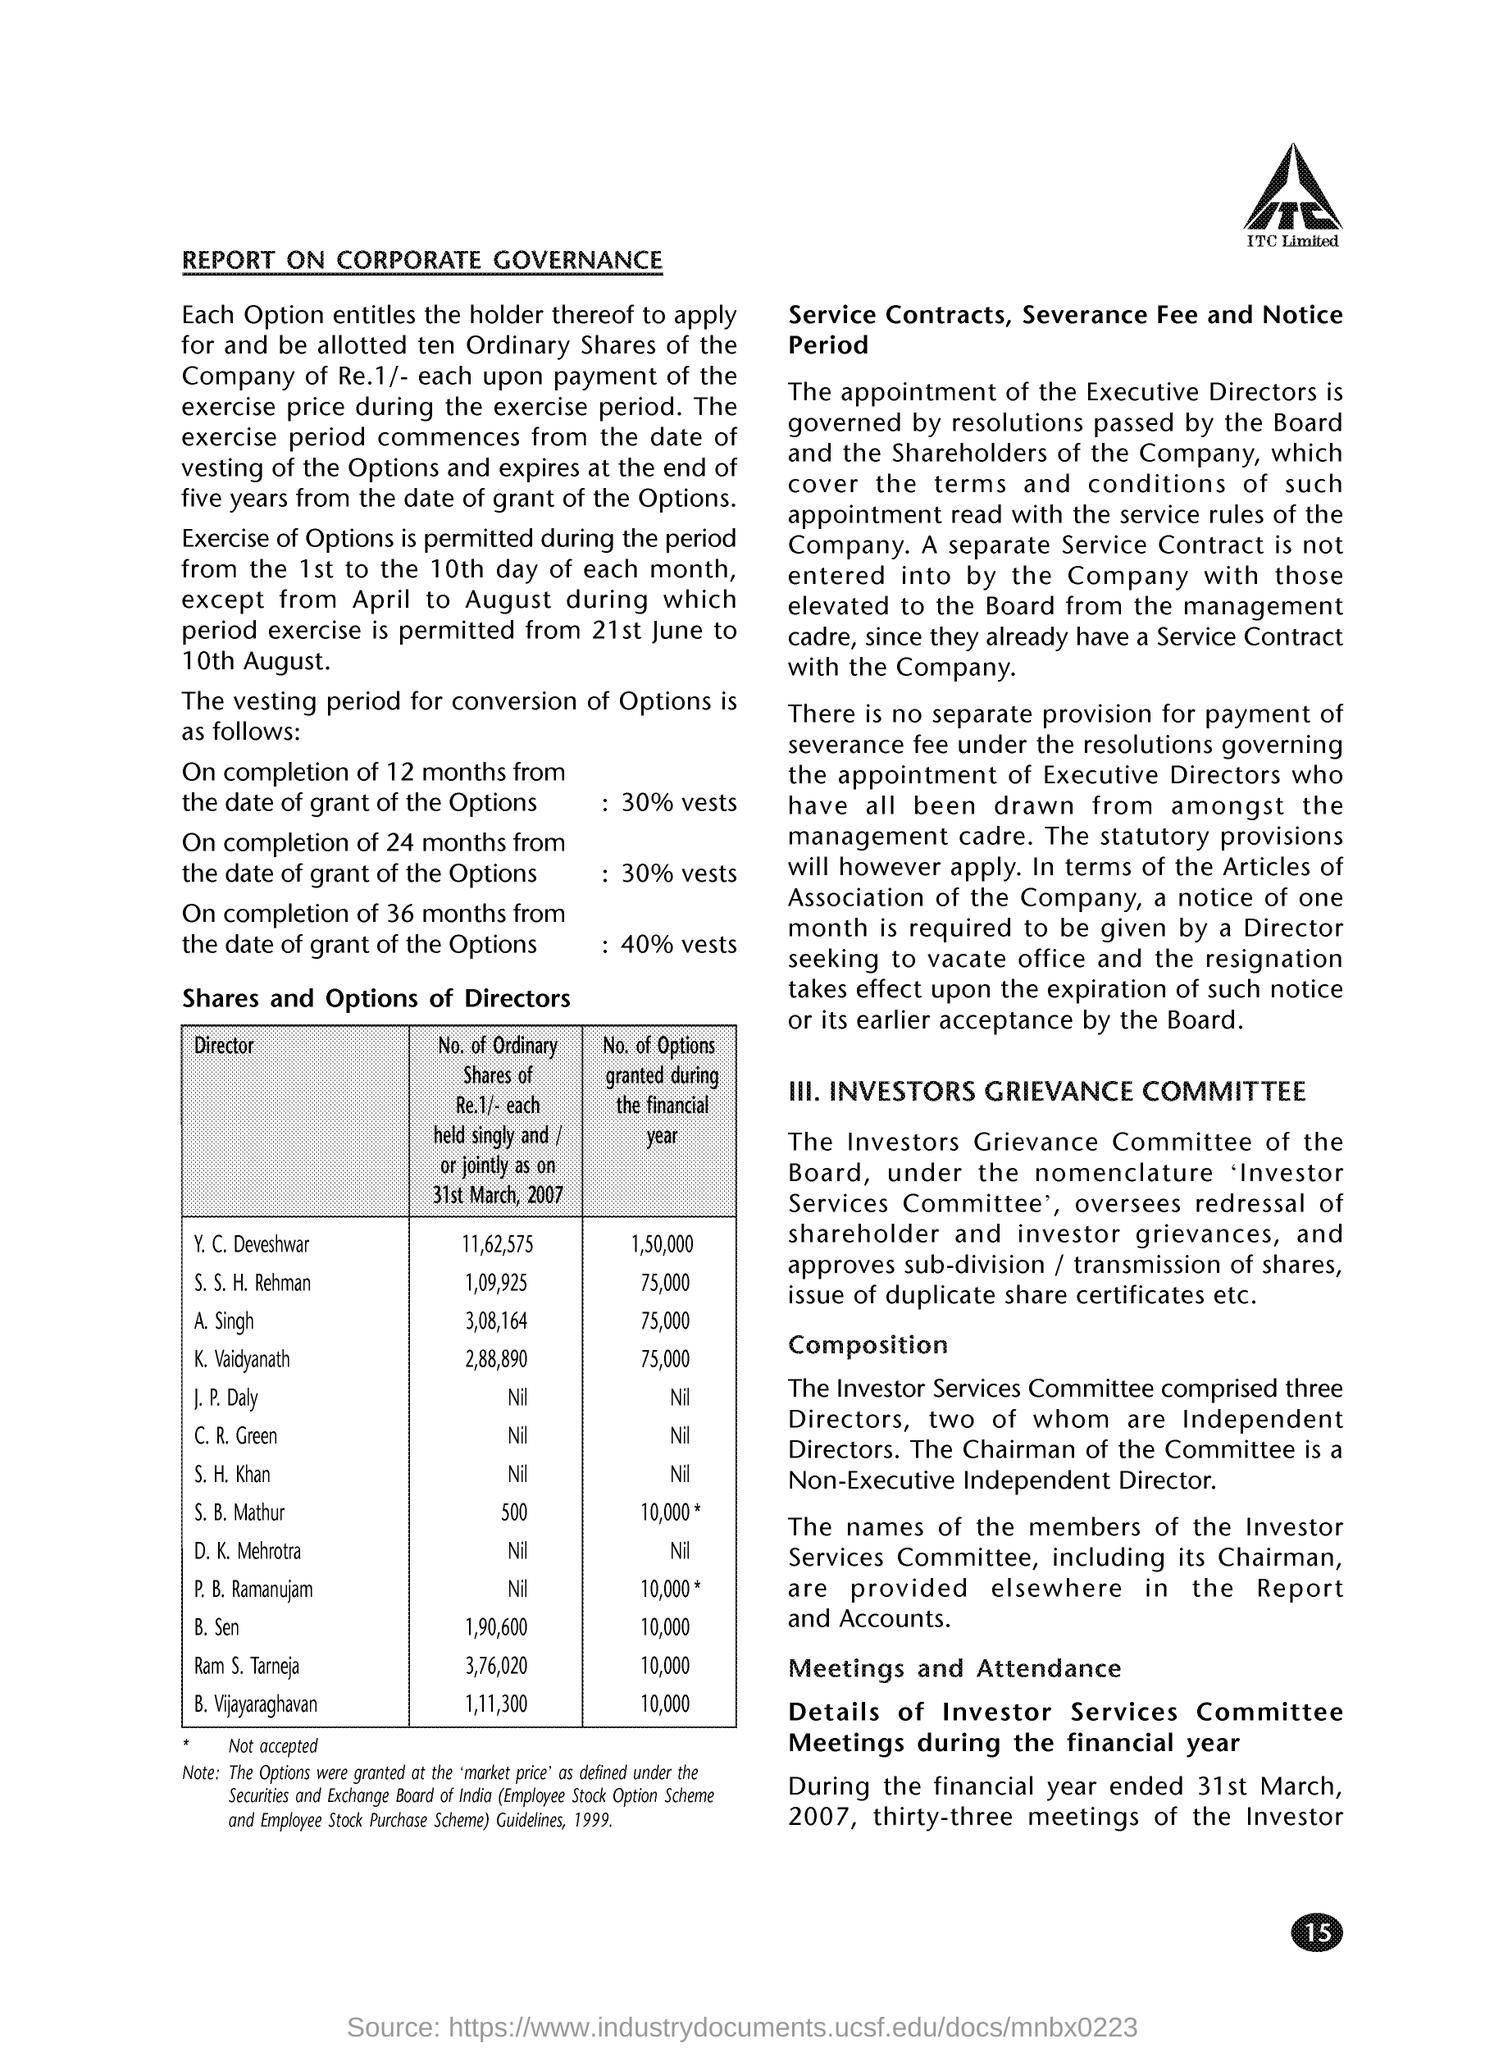Draw attention to some important aspects in this diagram. The number of options granted during the financial year for S. B. Mathur was [10,000]. During the financial year, a total of 10,000 options were granted to B. Sen. During the financial year, a total of 10,000 options were granted to B. Vijayaraghavan. During the financial year, the number of options granted to S. S. H. Rehman was 75,000. During the financial year, a total of 75,000 options were granted to K. Vaidyanathan. 